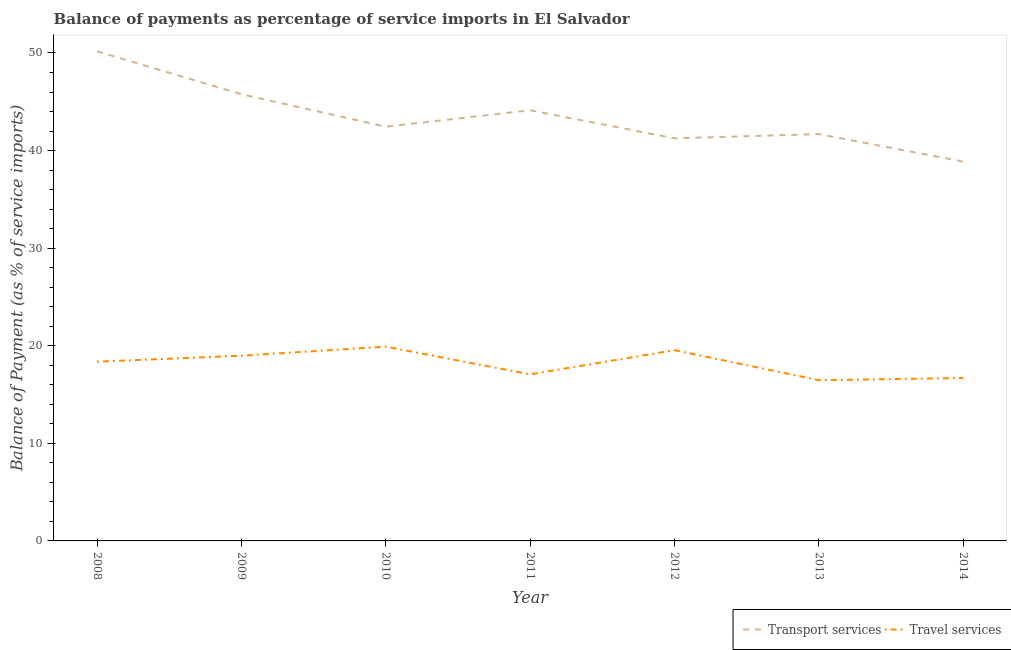Does the line corresponding to balance of payments of transport services intersect with the line corresponding to balance of payments of travel services?
Provide a succinct answer. No. Is the number of lines equal to the number of legend labels?
Offer a terse response. Yes. What is the balance of payments of transport services in 2012?
Your answer should be very brief. 41.25. Across all years, what is the maximum balance of payments of travel services?
Provide a short and direct response. 19.91. Across all years, what is the minimum balance of payments of transport services?
Offer a terse response. 38.87. In which year was the balance of payments of travel services maximum?
Offer a terse response. 2010. In which year was the balance of payments of transport services minimum?
Your response must be concise. 2014. What is the total balance of payments of transport services in the graph?
Ensure brevity in your answer.  304.34. What is the difference between the balance of payments of transport services in 2009 and that in 2011?
Ensure brevity in your answer.  1.65. What is the difference between the balance of payments of transport services in 2013 and the balance of payments of travel services in 2008?
Your answer should be very brief. 23.32. What is the average balance of payments of transport services per year?
Provide a succinct answer. 43.48. In the year 2013, what is the difference between the balance of payments of transport services and balance of payments of travel services?
Your response must be concise. 25.22. In how many years, is the balance of payments of transport services greater than 34 %?
Your response must be concise. 7. What is the ratio of the balance of payments of travel services in 2008 to that in 2010?
Give a very brief answer. 0.92. Is the balance of payments of transport services in 2009 less than that in 2014?
Offer a very short reply. No. What is the difference between the highest and the second highest balance of payments of travel services?
Give a very brief answer. 0.36. What is the difference between the highest and the lowest balance of payments of travel services?
Offer a terse response. 3.44. Does the balance of payments of travel services monotonically increase over the years?
Give a very brief answer. No. How many lines are there?
Make the answer very short. 2. How many years are there in the graph?
Make the answer very short. 7. What is the difference between two consecutive major ticks on the Y-axis?
Your answer should be very brief. 10. Does the graph contain any zero values?
Offer a terse response. No. Does the graph contain grids?
Make the answer very short. No. What is the title of the graph?
Your answer should be very brief. Balance of payments as percentage of service imports in El Salvador. Does "% of GNI" appear as one of the legend labels in the graph?
Your answer should be very brief. No. What is the label or title of the X-axis?
Keep it short and to the point. Year. What is the label or title of the Y-axis?
Provide a short and direct response. Balance of Payment (as % of service imports). What is the Balance of Payment (as % of service imports) in Transport services in 2008?
Provide a short and direct response. 50.17. What is the Balance of Payment (as % of service imports) of Travel services in 2008?
Your answer should be compact. 18.37. What is the Balance of Payment (as % of service imports) in Transport services in 2009?
Your answer should be very brief. 45.78. What is the Balance of Payment (as % of service imports) of Travel services in 2009?
Ensure brevity in your answer.  18.98. What is the Balance of Payment (as % of service imports) of Transport services in 2010?
Your answer should be compact. 42.44. What is the Balance of Payment (as % of service imports) in Travel services in 2010?
Keep it short and to the point. 19.91. What is the Balance of Payment (as % of service imports) of Transport services in 2011?
Your answer should be very brief. 44.13. What is the Balance of Payment (as % of service imports) of Travel services in 2011?
Make the answer very short. 17.07. What is the Balance of Payment (as % of service imports) in Transport services in 2012?
Provide a succinct answer. 41.25. What is the Balance of Payment (as % of service imports) in Travel services in 2012?
Offer a terse response. 19.55. What is the Balance of Payment (as % of service imports) in Transport services in 2013?
Ensure brevity in your answer.  41.69. What is the Balance of Payment (as % of service imports) of Travel services in 2013?
Provide a succinct answer. 16.47. What is the Balance of Payment (as % of service imports) in Transport services in 2014?
Ensure brevity in your answer.  38.87. What is the Balance of Payment (as % of service imports) of Travel services in 2014?
Ensure brevity in your answer.  16.7. Across all years, what is the maximum Balance of Payment (as % of service imports) in Transport services?
Ensure brevity in your answer.  50.17. Across all years, what is the maximum Balance of Payment (as % of service imports) in Travel services?
Give a very brief answer. 19.91. Across all years, what is the minimum Balance of Payment (as % of service imports) of Transport services?
Your answer should be compact. 38.87. Across all years, what is the minimum Balance of Payment (as % of service imports) in Travel services?
Your answer should be very brief. 16.47. What is the total Balance of Payment (as % of service imports) of Transport services in the graph?
Provide a short and direct response. 304.34. What is the total Balance of Payment (as % of service imports) in Travel services in the graph?
Make the answer very short. 127.04. What is the difference between the Balance of Payment (as % of service imports) of Transport services in 2008 and that in 2009?
Offer a very short reply. 4.39. What is the difference between the Balance of Payment (as % of service imports) in Travel services in 2008 and that in 2009?
Give a very brief answer. -0.61. What is the difference between the Balance of Payment (as % of service imports) in Transport services in 2008 and that in 2010?
Keep it short and to the point. 7.73. What is the difference between the Balance of Payment (as % of service imports) in Travel services in 2008 and that in 2010?
Your answer should be very brief. -1.54. What is the difference between the Balance of Payment (as % of service imports) of Transport services in 2008 and that in 2011?
Your answer should be very brief. 6.04. What is the difference between the Balance of Payment (as % of service imports) of Travel services in 2008 and that in 2011?
Keep it short and to the point. 1.3. What is the difference between the Balance of Payment (as % of service imports) of Transport services in 2008 and that in 2012?
Provide a short and direct response. 8.92. What is the difference between the Balance of Payment (as % of service imports) in Travel services in 2008 and that in 2012?
Your answer should be very brief. -1.18. What is the difference between the Balance of Payment (as % of service imports) in Transport services in 2008 and that in 2013?
Your response must be concise. 8.48. What is the difference between the Balance of Payment (as % of service imports) in Travel services in 2008 and that in 2013?
Your response must be concise. 1.9. What is the difference between the Balance of Payment (as % of service imports) in Transport services in 2008 and that in 2014?
Your answer should be compact. 11.3. What is the difference between the Balance of Payment (as % of service imports) of Travel services in 2008 and that in 2014?
Ensure brevity in your answer.  1.67. What is the difference between the Balance of Payment (as % of service imports) in Transport services in 2009 and that in 2010?
Offer a terse response. 3.33. What is the difference between the Balance of Payment (as % of service imports) in Travel services in 2009 and that in 2010?
Give a very brief answer. -0.93. What is the difference between the Balance of Payment (as % of service imports) of Transport services in 2009 and that in 2011?
Provide a succinct answer. 1.65. What is the difference between the Balance of Payment (as % of service imports) of Travel services in 2009 and that in 2011?
Give a very brief answer. 1.91. What is the difference between the Balance of Payment (as % of service imports) of Transport services in 2009 and that in 2012?
Give a very brief answer. 4.53. What is the difference between the Balance of Payment (as % of service imports) in Travel services in 2009 and that in 2012?
Your answer should be very brief. -0.57. What is the difference between the Balance of Payment (as % of service imports) in Transport services in 2009 and that in 2013?
Give a very brief answer. 4.09. What is the difference between the Balance of Payment (as % of service imports) in Travel services in 2009 and that in 2013?
Your response must be concise. 2.5. What is the difference between the Balance of Payment (as % of service imports) in Transport services in 2009 and that in 2014?
Your response must be concise. 6.91. What is the difference between the Balance of Payment (as % of service imports) in Travel services in 2009 and that in 2014?
Offer a very short reply. 2.28. What is the difference between the Balance of Payment (as % of service imports) of Transport services in 2010 and that in 2011?
Ensure brevity in your answer.  -1.69. What is the difference between the Balance of Payment (as % of service imports) in Travel services in 2010 and that in 2011?
Offer a very short reply. 2.84. What is the difference between the Balance of Payment (as % of service imports) of Transport services in 2010 and that in 2012?
Offer a terse response. 1.19. What is the difference between the Balance of Payment (as % of service imports) of Travel services in 2010 and that in 2012?
Ensure brevity in your answer.  0.36. What is the difference between the Balance of Payment (as % of service imports) of Transport services in 2010 and that in 2013?
Offer a terse response. 0.75. What is the difference between the Balance of Payment (as % of service imports) in Travel services in 2010 and that in 2013?
Give a very brief answer. 3.44. What is the difference between the Balance of Payment (as % of service imports) in Transport services in 2010 and that in 2014?
Give a very brief answer. 3.58. What is the difference between the Balance of Payment (as % of service imports) of Travel services in 2010 and that in 2014?
Give a very brief answer. 3.21. What is the difference between the Balance of Payment (as % of service imports) in Transport services in 2011 and that in 2012?
Make the answer very short. 2.88. What is the difference between the Balance of Payment (as % of service imports) in Travel services in 2011 and that in 2012?
Ensure brevity in your answer.  -2.48. What is the difference between the Balance of Payment (as % of service imports) of Transport services in 2011 and that in 2013?
Offer a very short reply. 2.44. What is the difference between the Balance of Payment (as % of service imports) in Travel services in 2011 and that in 2013?
Your answer should be very brief. 0.6. What is the difference between the Balance of Payment (as % of service imports) in Transport services in 2011 and that in 2014?
Keep it short and to the point. 5.26. What is the difference between the Balance of Payment (as % of service imports) in Travel services in 2011 and that in 2014?
Keep it short and to the point. 0.37. What is the difference between the Balance of Payment (as % of service imports) of Transport services in 2012 and that in 2013?
Offer a terse response. -0.44. What is the difference between the Balance of Payment (as % of service imports) in Travel services in 2012 and that in 2013?
Make the answer very short. 3.08. What is the difference between the Balance of Payment (as % of service imports) of Transport services in 2012 and that in 2014?
Make the answer very short. 2.38. What is the difference between the Balance of Payment (as % of service imports) in Travel services in 2012 and that in 2014?
Your answer should be compact. 2.85. What is the difference between the Balance of Payment (as % of service imports) in Transport services in 2013 and that in 2014?
Make the answer very short. 2.82. What is the difference between the Balance of Payment (as % of service imports) of Travel services in 2013 and that in 2014?
Provide a succinct answer. -0.22. What is the difference between the Balance of Payment (as % of service imports) in Transport services in 2008 and the Balance of Payment (as % of service imports) in Travel services in 2009?
Ensure brevity in your answer.  31.19. What is the difference between the Balance of Payment (as % of service imports) in Transport services in 2008 and the Balance of Payment (as % of service imports) in Travel services in 2010?
Your answer should be compact. 30.26. What is the difference between the Balance of Payment (as % of service imports) in Transport services in 2008 and the Balance of Payment (as % of service imports) in Travel services in 2011?
Offer a very short reply. 33.1. What is the difference between the Balance of Payment (as % of service imports) in Transport services in 2008 and the Balance of Payment (as % of service imports) in Travel services in 2012?
Offer a very short reply. 30.62. What is the difference between the Balance of Payment (as % of service imports) of Transport services in 2008 and the Balance of Payment (as % of service imports) of Travel services in 2013?
Ensure brevity in your answer.  33.7. What is the difference between the Balance of Payment (as % of service imports) of Transport services in 2008 and the Balance of Payment (as % of service imports) of Travel services in 2014?
Offer a very short reply. 33.48. What is the difference between the Balance of Payment (as % of service imports) in Transport services in 2009 and the Balance of Payment (as % of service imports) in Travel services in 2010?
Keep it short and to the point. 25.87. What is the difference between the Balance of Payment (as % of service imports) in Transport services in 2009 and the Balance of Payment (as % of service imports) in Travel services in 2011?
Ensure brevity in your answer.  28.71. What is the difference between the Balance of Payment (as % of service imports) in Transport services in 2009 and the Balance of Payment (as % of service imports) in Travel services in 2012?
Give a very brief answer. 26.23. What is the difference between the Balance of Payment (as % of service imports) in Transport services in 2009 and the Balance of Payment (as % of service imports) in Travel services in 2013?
Your response must be concise. 29.31. What is the difference between the Balance of Payment (as % of service imports) of Transport services in 2009 and the Balance of Payment (as % of service imports) of Travel services in 2014?
Offer a terse response. 29.08. What is the difference between the Balance of Payment (as % of service imports) in Transport services in 2010 and the Balance of Payment (as % of service imports) in Travel services in 2011?
Make the answer very short. 25.38. What is the difference between the Balance of Payment (as % of service imports) in Transport services in 2010 and the Balance of Payment (as % of service imports) in Travel services in 2012?
Your response must be concise. 22.9. What is the difference between the Balance of Payment (as % of service imports) of Transport services in 2010 and the Balance of Payment (as % of service imports) of Travel services in 2013?
Make the answer very short. 25.97. What is the difference between the Balance of Payment (as % of service imports) of Transport services in 2010 and the Balance of Payment (as % of service imports) of Travel services in 2014?
Offer a terse response. 25.75. What is the difference between the Balance of Payment (as % of service imports) of Transport services in 2011 and the Balance of Payment (as % of service imports) of Travel services in 2012?
Provide a short and direct response. 24.58. What is the difference between the Balance of Payment (as % of service imports) in Transport services in 2011 and the Balance of Payment (as % of service imports) in Travel services in 2013?
Keep it short and to the point. 27.66. What is the difference between the Balance of Payment (as % of service imports) in Transport services in 2011 and the Balance of Payment (as % of service imports) in Travel services in 2014?
Provide a short and direct response. 27.44. What is the difference between the Balance of Payment (as % of service imports) of Transport services in 2012 and the Balance of Payment (as % of service imports) of Travel services in 2013?
Give a very brief answer. 24.78. What is the difference between the Balance of Payment (as % of service imports) of Transport services in 2012 and the Balance of Payment (as % of service imports) of Travel services in 2014?
Give a very brief answer. 24.56. What is the difference between the Balance of Payment (as % of service imports) of Transport services in 2013 and the Balance of Payment (as % of service imports) of Travel services in 2014?
Provide a short and direct response. 25. What is the average Balance of Payment (as % of service imports) in Transport services per year?
Your answer should be very brief. 43.48. What is the average Balance of Payment (as % of service imports) in Travel services per year?
Your response must be concise. 18.15. In the year 2008, what is the difference between the Balance of Payment (as % of service imports) of Transport services and Balance of Payment (as % of service imports) of Travel services?
Your response must be concise. 31.8. In the year 2009, what is the difference between the Balance of Payment (as % of service imports) of Transport services and Balance of Payment (as % of service imports) of Travel services?
Ensure brevity in your answer.  26.8. In the year 2010, what is the difference between the Balance of Payment (as % of service imports) of Transport services and Balance of Payment (as % of service imports) of Travel services?
Provide a succinct answer. 22.54. In the year 2011, what is the difference between the Balance of Payment (as % of service imports) of Transport services and Balance of Payment (as % of service imports) of Travel services?
Offer a very short reply. 27.06. In the year 2012, what is the difference between the Balance of Payment (as % of service imports) in Transport services and Balance of Payment (as % of service imports) in Travel services?
Your answer should be very brief. 21.7. In the year 2013, what is the difference between the Balance of Payment (as % of service imports) of Transport services and Balance of Payment (as % of service imports) of Travel services?
Make the answer very short. 25.22. In the year 2014, what is the difference between the Balance of Payment (as % of service imports) of Transport services and Balance of Payment (as % of service imports) of Travel services?
Offer a terse response. 22.17. What is the ratio of the Balance of Payment (as % of service imports) of Transport services in 2008 to that in 2009?
Offer a terse response. 1.1. What is the ratio of the Balance of Payment (as % of service imports) of Transport services in 2008 to that in 2010?
Ensure brevity in your answer.  1.18. What is the ratio of the Balance of Payment (as % of service imports) of Travel services in 2008 to that in 2010?
Your answer should be very brief. 0.92. What is the ratio of the Balance of Payment (as % of service imports) in Transport services in 2008 to that in 2011?
Ensure brevity in your answer.  1.14. What is the ratio of the Balance of Payment (as % of service imports) in Travel services in 2008 to that in 2011?
Ensure brevity in your answer.  1.08. What is the ratio of the Balance of Payment (as % of service imports) in Transport services in 2008 to that in 2012?
Provide a short and direct response. 1.22. What is the ratio of the Balance of Payment (as % of service imports) of Travel services in 2008 to that in 2012?
Keep it short and to the point. 0.94. What is the ratio of the Balance of Payment (as % of service imports) in Transport services in 2008 to that in 2013?
Keep it short and to the point. 1.2. What is the ratio of the Balance of Payment (as % of service imports) in Travel services in 2008 to that in 2013?
Provide a succinct answer. 1.12. What is the ratio of the Balance of Payment (as % of service imports) of Transport services in 2008 to that in 2014?
Keep it short and to the point. 1.29. What is the ratio of the Balance of Payment (as % of service imports) in Travel services in 2008 to that in 2014?
Keep it short and to the point. 1.1. What is the ratio of the Balance of Payment (as % of service imports) of Transport services in 2009 to that in 2010?
Offer a terse response. 1.08. What is the ratio of the Balance of Payment (as % of service imports) in Travel services in 2009 to that in 2010?
Your answer should be compact. 0.95. What is the ratio of the Balance of Payment (as % of service imports) in Transport services in 2009 to that in 2011?
Give a very brief answer. 1.04. What is the ratio of the Balance of Payment (as % of service imports) of Travel services in 2009 to that in 2011?
Your answer should be very brief. 1.11. What is the ratio of the Balance of Payment (as % of service imports) in Transport services in 2009 to that in 2012?
Keep it short and to the point. 1.11. What is the ratio of the Balance of Payment (as % of service imports) of Travel services in 2009 to that in 2012?
Provide a short and direct response. 0.97. What is the ratio of the Balance of Payment (as % of service imports) in Transport services in 2009 to that in 2013?
Your answer should be very brief. 1.1. What is the ratio of the Balance of Payment (as % of service imports) in Travel services in 2009 to that in 2013?
Provide a succinct answer. 1.15. What is the ratio of the Balance of Payment (as % of service imports) in Transport services in 2009 to that in 2014?
Your response must be concise. 1.18. What is the ratio of the Balance of Payment (as % of service imports) of Travel services in 2009 to that in 2014?
Make the answer very short. 1.14. What is the ratio of the Balance of Payment (as % of service imports) in Transport services in 2010 to that in 2011?
Provide a short and direct response. 0.96. What is the ratio of the Balance of Payment (as % of service imports) of Travel services in 2010 to that in 2011?
Keep it short and to the point. 1.17. What is the ratio of the Balance of Payment (as % of service imports) in Transport services in 2010 to that in 2012?
Your answer should be very brief. 1.03. What is the ratio of the Balance of Payment (as % of service imports) of Travel services in 2010 to that in 2012?
Offer a very short reply. 1.02. What is the ratio of the Balance of Payment (as % of service imports) of Transport services in 2010 to that in 2013?
Provide a succinct answer. 1.02. What is the ratio of the Balance of Payment (as % of service imports) in Travel services in 2010 to that in 2013?
Make the answer very short. 1.21. What is the ratio of the Balance of Payment (as % of service imports) in Transport services in 2010 to that in 2014?
Your answer should be very brief. 1.09. What is the ratio of the Balance of Payment (as % of service imports) of Travel services in 2010 to that in 2014?
Keep it short and to the point. 1.19. What is the ratio of the Balance of Payment (as % of service imports) in Transport services in 2011 to that in 2012?
Keep it short and to the point. 1.07. What is the ratio of the Balance of Payment (as % of service imports) in Travel services in 2011 to that in 2012?
Keep it short and to the point. 0.87. What is the ratio of the Balance of Payment (as % of service imports) of Transport services in 2011 to that in 2013?
Your response must be concise. 1.06. What is the ratio of the Balance of Payment (as % of service imports) in Travel services in 2011 to that in 2013?
Provide a succinct answer. 1.04. What is the ratio of the Balance of Payment (as % of service imports) of Transport services in 2011 to that in 2014?
Make the answer very short. 1.14. What is the ratio of the Balance of Payment (as % of service imports) in Travel services in 2011 to that in 2014?
Your response must be concise. 1.02. What is the ratio of the Balance of Payment (as % of service imports) in Travel services in 2012 to that in 2013?
Keep it short and to the point. 1.19. What is the ratio of the Balance of Payment (as % of service imports) in Transport services in 2012 to that in 2014?
Your answer should be compact. 1.06. What is the ratio of the Balance of Payment (as % of service imports) of Travel services in 2012 to that in 2014?
Your answer should be compact. 1.17. What is the ratio of the Balance of Payment (as % of service imports) in Transport services in 2013 to that in 2014?
Provide a succinct answer. 1.07. What is the ratio of the Balance of Payment (as % of service imports) of Travel services in 2013 to that in 2014?
Your response must be concise. 0.99. What is the difference between the highest and the second highest Balance of Payment (as % of service imports) of Transport services?
Ensure brevity in your answer.  4.39. What is the difference between the highest and the second highest Balance of Payment (as % of service imports) in Travel services?
Your response must be concise. 0.36. What is the difference between the highest and the lowest Balance of Payment (as % of service imports) in Transport services?
Keep it short and to the point. 11.3. What is the difference between the highest and the lowest Balance of Payment (as % of service imports) of Travel services?
Provide a short and direct response. 3.44. 